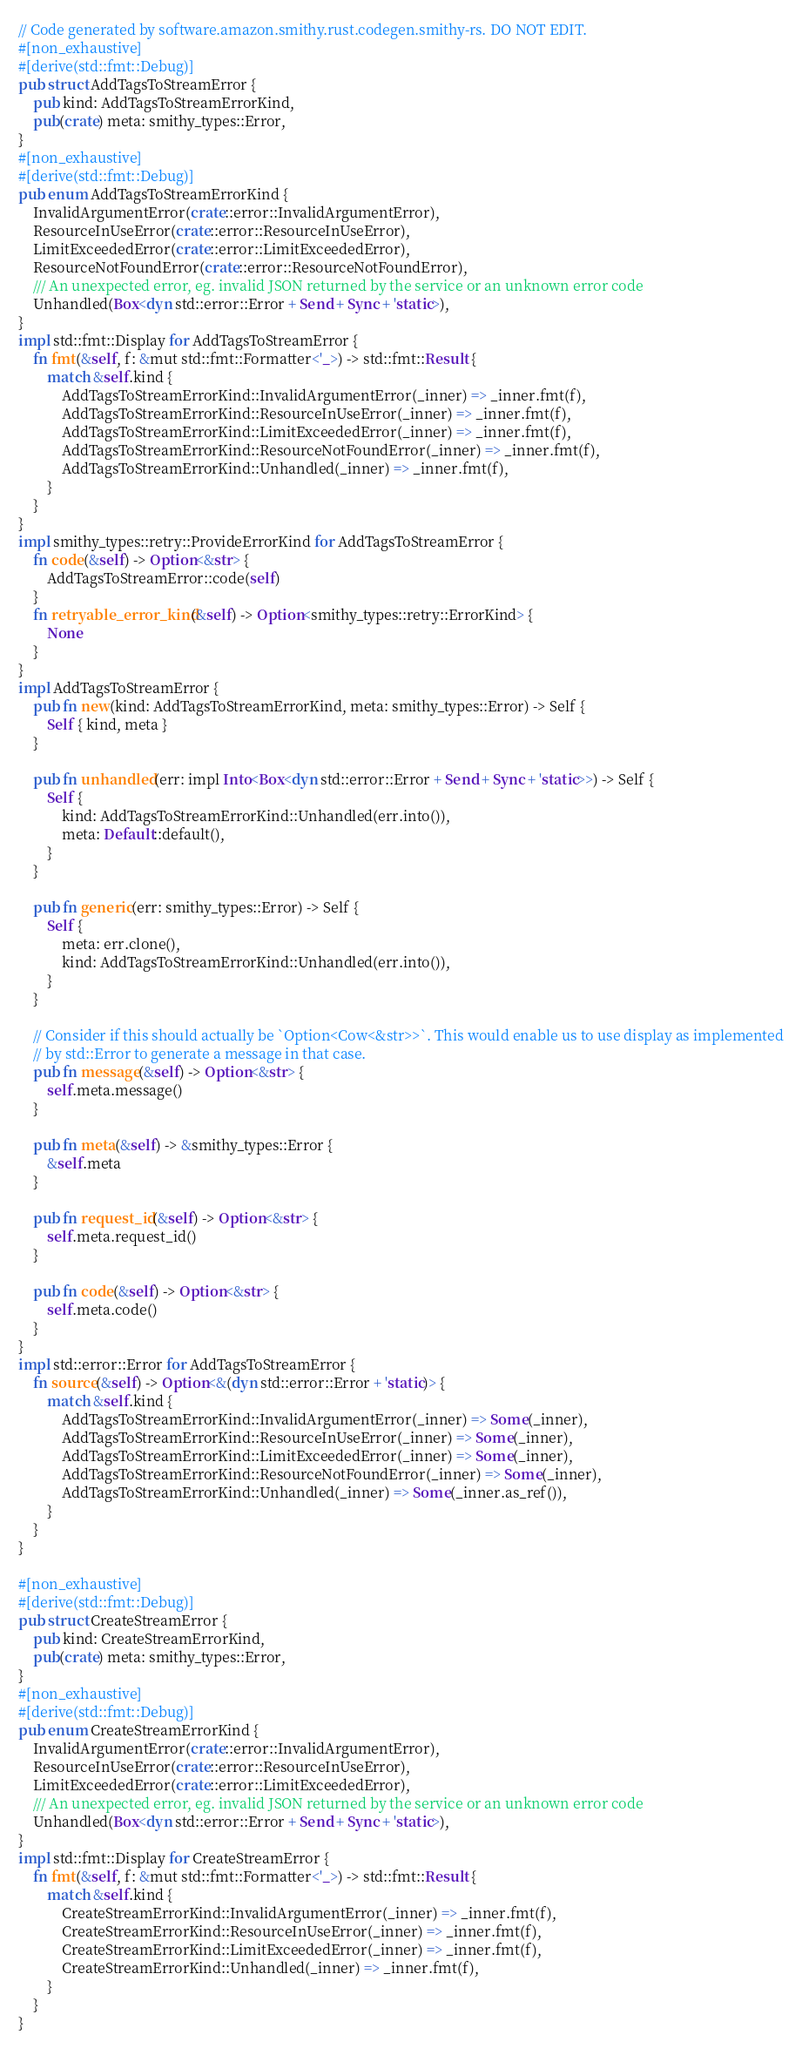Convert code to text. <code><loc_0><loc_0><loc_500><loc_500><_Rust_>// Code generated by software.amazon.smithy.rust.codegen.smithy-rs. DO NOT EDIT.
#[non_exhaustive]
#[derive(std::fmt::Debug)]
pub struct AddTagsToStreamError {
    pub kind: AddTagsToStreamErrorKind,
    pub(crate) meta: smithy_types::Error,
}
#[non_exhaustive]
#[derive(std::fmt::Debug)]
pub enum AddTagsToStreamErrorKind {
    InvalidArgumentError(crate::error::InvalidArgumentError),
    ResourceInUseError(crate::error::ResourceInUseError),
    LimitExceededError(crate::error::LimitExceededError),
    ResourceNotFoundError(crate::error::ResourceNotFoundError),
    /// An unexpected error, eg. invalid JSON returned by the service or an unknown error code
    Unhandled(Box<dyn std::error::Error + Send + Sync + 'static>),
}
impl std::fmt::Display for AddTagsToStreamError {
    fn fmt(&self, f: &mut std::fmt::Formatter<'_>) -> std::fmt::Result {
        match &self.kind {
            AddTagsToStreamErrorKind::InvalidArgumentError(_inner) => _inner.fmt(f),
            AddTagsToStreamErrorKind::ResourceInUseError(_inner) => _inner.fmt(f),
            AddTagsToStreamErrorKind::LimitExceededError(_inner) => _inner.fmt(f),
            AddTagsToStreamErrorKind::ResourceNotFoundError(_inner) => _inner.fmt(f),
            AddTagsToStreamErrorKind::Unhandled(_inner) => _inner.fmt(f),
        }
    }
}
impl smithy_types::retry::ProvideErrorKind for AddTagsToStreamError {
    fn code(&self) -> Option<&str> {
        AddTagsToStreamError::code(self)
    }
    fn retryable_error_kind(&self) -> Option<smithy_types::retry::ErrorKind> {
        None
    }
}
impl AddTagsToStreamError {
    pub fn new(kind: AddTagsToStreamErrorKind, meta: smithy_types::Error) -> Self {
        Self { kind, meta }
    }

    pub fn unhandled(err: impl Into<Box<dyn std::error::Error + Send + Sync + 'static>>) -> Self {
        Self {
            kind: AddTagsToStreamErrorKind::Unhandled(err.into()),
            meta: Default::default(),
        }
    }

    pub fn generic(err: smithy_types::Error) -> Self {
        Self {
            meta: err.clone(),
            kind: AddTagsToStreamErrorKind::Unhandled(err.into()),
        }
    }

    // Consider if this should actually be `Option<Cow<&str>>`. This would enable us to use display as implemented
    // by std::Error to generate a message in that case.
    pub fn message(&self) -> Option<&str> {
        self.meta.message()
    }

    pub fn meta(&self) -> &smithy_types::Error {
        &self.meta
    }

    pub fn request_id(&self) -> Option<&str> {
        self.meta.request_id()
    }

    pub fn code(&self) -> Option<&str> {
        self.meta.code()
    }
}
impl std::error::Error for AddTagsToStreamError {
    fn source(&self) -> Option<&(dyn std::error::Error + 'static)> {
        match &self.kind {
            AddTagsToStreamErrorKind::InvalidArgumentError(_inner) => Some(_inner),
            AddTagsToStreamErrorKind::ResourceInUseError(_inner) => Some(_inner),
            AddTagsToStreamErrorKind::LimitExceededError(_inner) => Some(_inner),
            AddTagsToStreamErrorKind::ResourceNotFoundError(_inner) => Some(_inner),
            AddTagsToStreamErrorKind::Unhandled(_inner) => Some(_inner.as_ref()),
        }
    }
}

#[non_exhaustive]
#[derive(std::fmt::Debug)]
pub struct CreateStreamError {
    pub kind: CreateStreamErrorKind,
    pub(crate) meta: smithy_types::Error,
}
#[non_exhaustive]
#[derive(std::fmt::Debug)]
pub enum CreateStreamErrorKind {
    InvalidArgumentError(crate::error::InvalidArgumentError),
    ResourceInUseError(crate::error::ResourceInUseError),
    LimitExceededError(crate::error::LimitExceededError),
    /// An unexpected error, eg. invalid JSON returned by the service or an unknown error code
    Unhandled(Box<dyn std::error::Error + Send + Sync + 'static>),
}
impl std::fmt::Display for CreateStreamError {
    fn fmt(&self, f: &mut std::fmt::Formatter<'_>) -> std::fmt::Result {
        match &self.kind {
            CreateStreamErrorKind::InvalidArgumentError(_inner) => _inner.fmt(f),
            CreateStreamErrorKind::ResourceInUseError(_inner) => _inner.fmt(f),
            CreateStreamErrorKind::LimitExceededError(_inner) => _inner.fmt(f),
            CreateStreamErrorKind::Unhandled(_inner) => _inner.fmt(f),
        }
    }
}</code> 